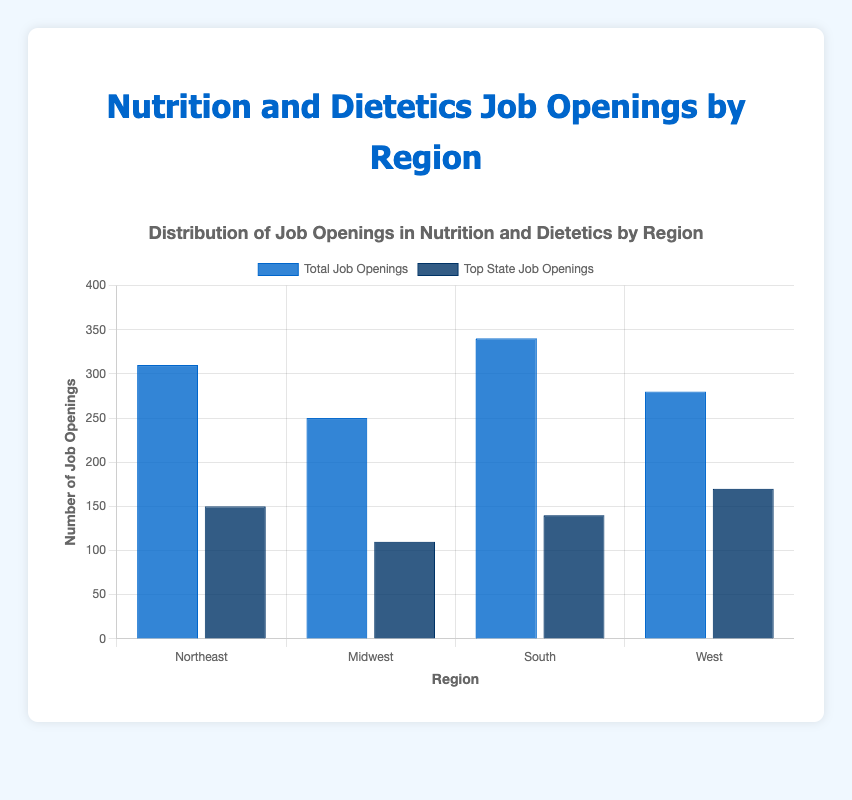How many job openings are there in the Northeast region compared to the South region? The figure shows that the Northeast has 310 job openings and the South has 340 job openings. To compare, subtract the Northeast's job openings from the South's. Thus, 340 - 310 = 30.
Answer: 30 Which region has the highest total number of job openings, and how many more openings does it have compared to the Midwest region? The South has the highest total number of job openings with 340. The Midwest has 250 job openings. The difference is 340 - 250 = 90.
Answer: South, 90 Which state has the highest number of job openings in the West region? In the West region, California has the highest number of job openings at 170. This is the tallest dark blue bar for the West region.
Answer: California Which region has the smallest difference between its total job openings and its top state job openings? Calculate the differences:
Northeast: 310 - 150 = 160
Midwest: 250 - 110 = 140
South: 340 - 140 = 200
West: 280 - 170 = 110. The West has the smallest difference of 110.
Answer: West What is the average number of job openings per state in the Northeast region? The Northeast region consists of three states with job openings 150, 90, and 70. Sum these values and divide by the number of states: (150 + 90 + 70) / 3 = 310 / 3 ≈ 103.33.
Answer: Approximately 103.33 If the job openings in the state with the lowest number of openings in each region were doubled, which region would have the highest increase in total job openings? Calculate the additional job openings:
Pennsylvania: 70 * 2 = 140, increase = 140 - 70 = 70
Michigan: 60 * 2 = 120, increase = 120 - 60 = 60
Georgia: 70 * 2 = 140, increase = 140 - 70 = 70
Colorado: 50 * 2 = 100, increase = 100 - 50 = 50. The Northeast and South regions have the highest increase of 70.
Answer: Northeast and South Considering the current data, what is the total number of job openings across all regions? To find the total job openings across all regions, sum the total job openings for each region: 310 (Northeast) + 250 (Midwest) + 340 (South) + 280 (West) = 1180.
Answer: 1180 Visualizing the bars, how does the color scheme assist in understanding the distribution of job openings by region and state? The bars use two shades of blue, with dark blue representing the top state job openings and lighter blue for the total job openings in each region. This color distinction helps easily identify and compare the main contributing state to the total job openings within each region.
Answer: Clear differentiation by color Which region's top state contributes the most significantly to its total job openings? Calculate the contribution percentage of the top state in each region:
Northeast: (150 / 310) * 100 ≈ 48.39%
Midwest: (110 / 250) * 100 = 44%
South: (140 / 340) * 100 ≈ 41.18%
West: (170 / 280) * 100 ≈ 60.71%. California in the West has the highest contribution at approximately 60.71%.
Answer: West 